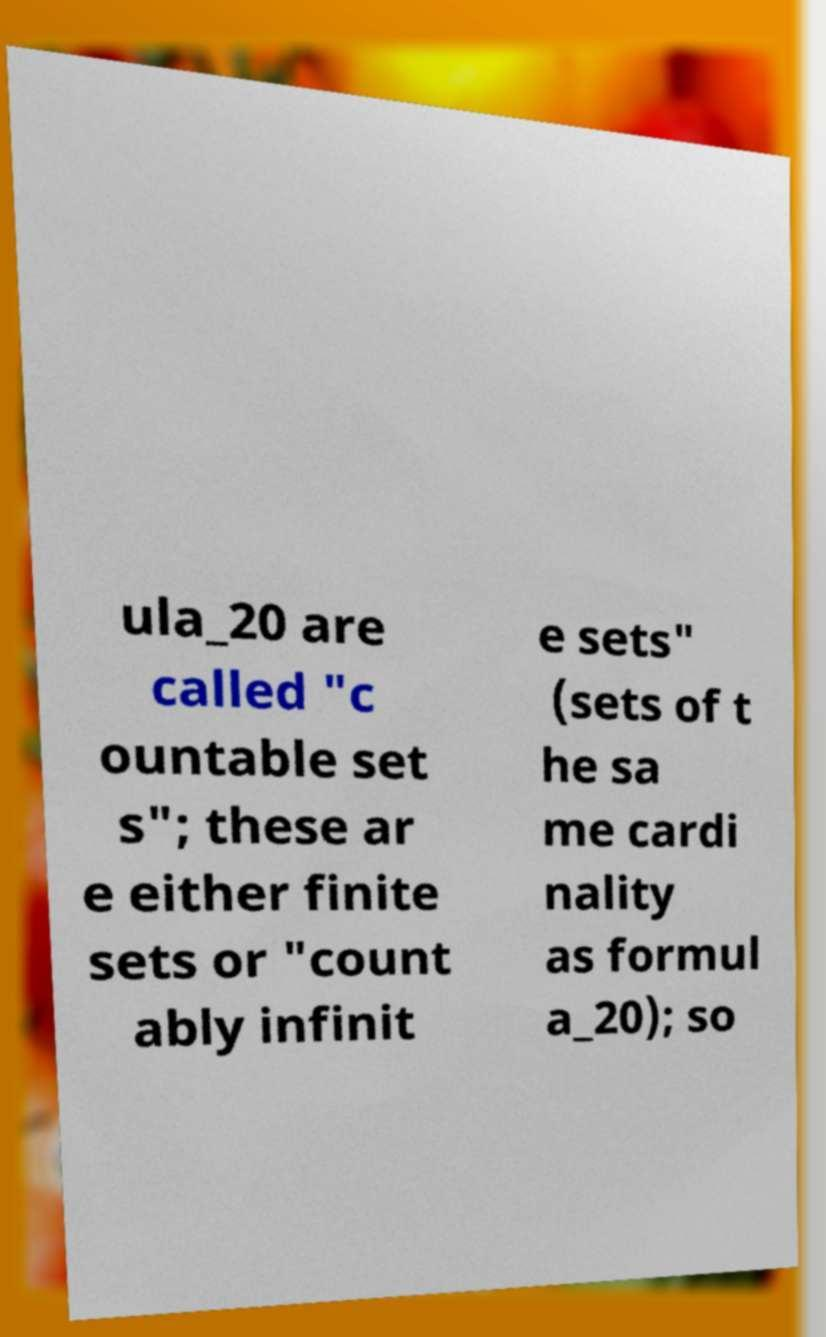What messages or text are displayed in this image? I need them in a readable, typed format. ula_20 are called "c ountable set s"; these ar e either finite sets or "count ably infinit e sets" (sets of t he sa me cardi nality as formul a_20); so 